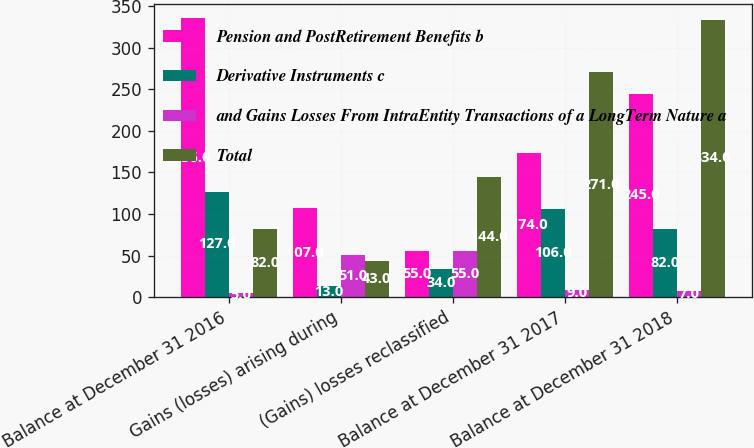<chart> <loc_0><loc_0><loc_500><loc_500><stacked_bar_chart><ecel><fcel>Balance at December 31 2016<fcel>Gains (losses) arising during<fcel>(Gains) losses reclassified<fcel>Balance at December 31 2017<fcel>Balance at December 31 2018<nl><fcel>Pension and PostRetirement Benefits b<fcel>336<fcel>107<fcel>55<fcel>174<fcel>245<nl><fcel>Derivative Instruments c<fcel>127<fcel>13<fcel>34<fcel>106<fcel>82<nl><fcel>and Gains Losses From IntraEntity Transactions of a LongTerm Nature a<fcel>5<fcel>51<fcel>55<fcel>9<fcel>7<nl><fcel>Total<fcel>82<fcel>43<fcel>144<fcel>271<fcel>334<nl></chart> 